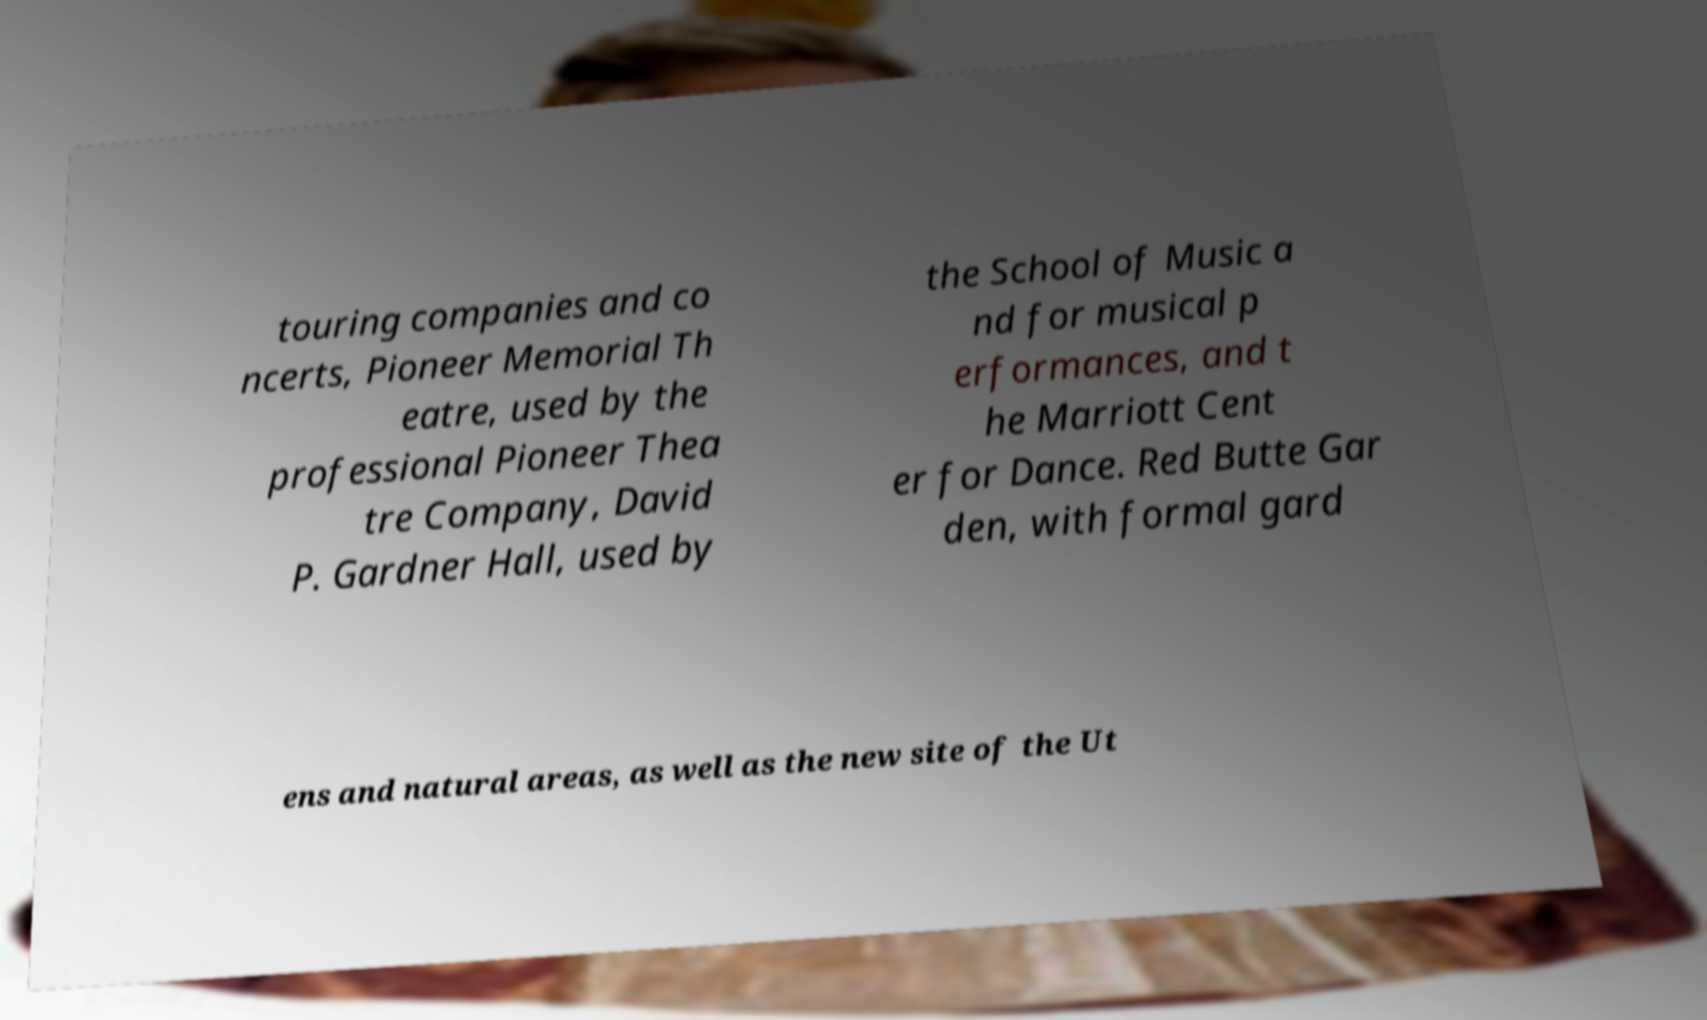Could you extract and type out the text from this image? touring companies and co ncerts, Pioneer Memorial Th eatre, used by the professional Pioneer Thea tre Company, David P. Gardner Hall, used by the School of Music a nd for musical p erformances, and t he Marriott Cent er for Dance. Red Butte Gar den, with formal gard ens and natural areas, as well as the new site of the Ut 